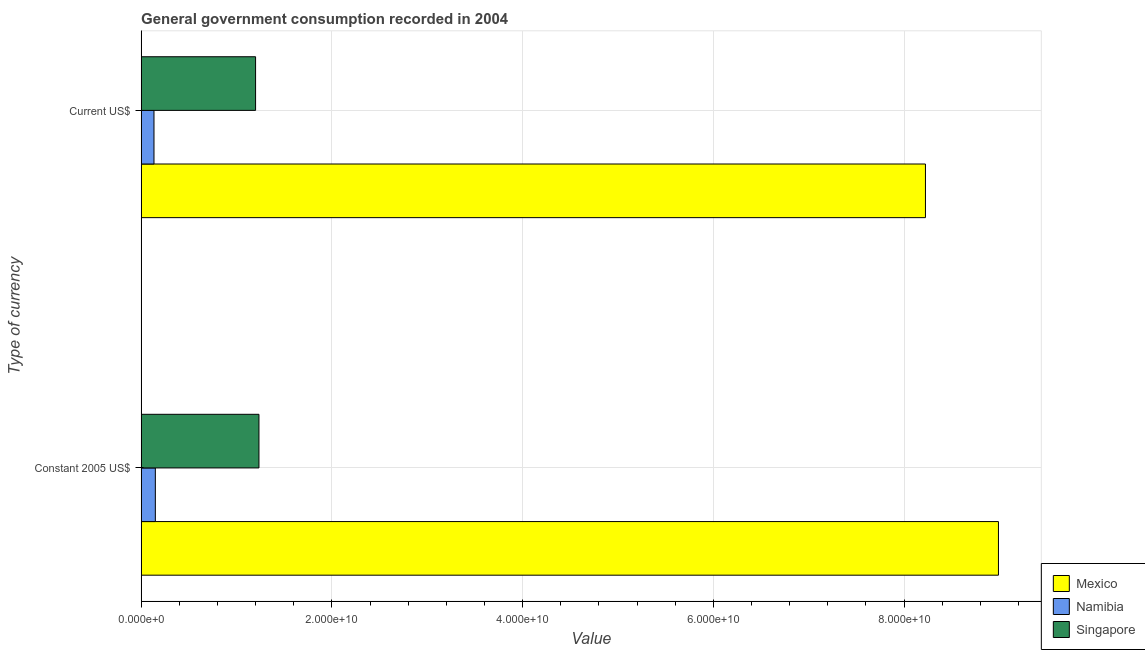How many different coloured bars are there?
Provide a succinct answer. 3. Are the number of bars per tick equal to the number of legend labels?
Your answer should be compact. Yes. What is the label of the 1st group of bars from the top?
Your response must be concise. Current US$. What is the value consumed in current us$ in Singapore?
Keep it short and to the point. 1.20e+1. Across all countries, what is the maximum value consumed in current us$?
Ensure brevity in your answer.  8.22e+1. Across all countries, what is the minimum value consumed in constant 2005 us$?
Provide a succinct answer. 1.49e+09. In which country was the value consumed in constant 2005 us$ maximum?
Your answer should be compact. Mexico. In which country was the value consumed in current us$ minimum?
Your answer should be very brief. Namibia. What is the total value consumed in constant 2005 us$ in the graph?
Offer a very short reply. 1.04e+11. What is the difference between the value consumed in current us$ in Mexico and that in Namibia?
Offer a very short reply. 8.09e+1. What is the difference between the value consumed in current us$ in Namibia and the value consumed in constant 2005 us$ in Mexico?
Provide a succinct answer. -8.86e+1. What is the average value consumed in constant 2005 us$ per country?
Provide a short and direct response. 3.46e+1. What is the difference between the value consumed in current us$ and value consumed in constant 2005 us$ in Singapore?
Your answer should be compact. -3.54e+08. What is the ratio of the value consumed in constant 2005 us$ in Singapore to that in Mexico?
Your answer should be very brief. 0.14. In how many countries, is the value consumed in current us$ greater than the average value consumed in current us$ taken over all countries?
Ensure brevity in your answer.  1. What does the 1st bar from the top in Constant 2005 US$ represents?
Ensure brevity in your answer.  Singapore. What does the 3rd bar from the bottom in Constant 2005 US$ represents?
Your response must be concise. Singapore. How many bars are there?
Your answer should be very brief. 6. What is the difference between two consecutive major ticks on the X-axis?
Provide a short and direct response. 2.00e+1. Does the graph contain any zero values?
Make the answer very short. No. What is the title of the graph?
Ensure brevity in your answer.  General government consumption recorded in 2004. Does "Nicaragua" appear as one of the legend labels in the graph?
Offer a very short reply. No. What is the label or title of the X-axis?
Provide a short and direct response. Value. What is the label or title of the Y-axis?
Your answer should be very brief. Type of currency. What is the Value in Mexico in Constant 2005 US$?
Offer a terse response. 8.99e+1. What is the Value in Namibia in Constant 2005 US$?
Provide a short and direct response. 1.49e+09. What is the Value of Singapore in Constant 2005 US$?
Offer a very short reply. 1.24e+1. What is the Value of Mexico in Current US$?
Offer a very short reply. 8.22e+1. What is the Value of Namibia in Current US$?
Your answer should be very brief. 1.35e+09. What is the Value in Singapore in Current US$?
Ensure brevity in your answer.  1.20e+1. Across all Type of currency, what is the maximum Value of Mexico?
Provide a short and direct response. 8.99e+1. Across all Type of currency, what is the maximum Value in Namibia?
Ensure brevity in your answer.  1.49e+09. Across all Type of currency, what is the maximum Value in Singapore?
Provide a succinct answer. 1.24e+1. Across all Type of currency, what is the minimum Value in Mexico?
Your response must be concise. 8.22e+1. Across all Type of currency, what is the minimum Value of Namibia?
Your answer should be very brief. 1.35e+09. Across all Type of currency, what is the minimum Value of Singapore?
Give a very brief answer. 1.20e+1. What is the total Value of Mexico in the graph?
Ensure brevity in your answer.  1.72e+11. What is the total Value of Namibia in the graph?
Keep it short and to the point. 2.83e+09. What is the total Value in Singapore in the graph?
Make the answer very short. 2.44e+1. What is the difference between the Value in Mexico in Constant 2005 US$ and that in Current US$?
Offer a very short reply. 7.66e+09. What is the difference between the Value in Namibia in Constant 2005 US$ and that in Current US$?
Ensure brevity in your answer.  1.43e+08. What is the difference between the Value of Singapore in Constant 2005 US$ and that in Current US$?
Your answer should be compact. 3.54e+08. What is the difference between the Value in Mexico in Constant 2005 US$ and the Value in Namibia in Current US$?
Give a very brief answer. 8.86e+1. What is the difference between the Value of Mexico in Constant 2005 US$ and the Value of Singapore in Current US$?
Ensure brevity in your answer.  7.79e+1. What is the difference between the Value of Namibia in Constant 2005 US$ and the Value of Singapore in Current US$?
Make the answer very short. -1.05e+1. What is the average Value of Mexico per Type of currency?
Give a very brief answer. 8.61e+1. What is the average Value in Namibia per Type of currency?
Make the answer very short. 1.42e+09. What is the average Value in Singapore per Type of currency?
Offer a very short reply. 1.22e+1. What is the difference between the Value of Mexico and Value of Namibia in Constant 2005 US$?
Your answer should be compact. 8.84e+1. What is the difference between the Value in Mexico and Value in Singapore in Constant 2005 US$?
Offer a terse response. 7.76e+1. What is the difference between the Value in Namibia and Value in Singapore in Constant 2005 US$?
Ensure brevity in your answer.  -1.09e+1. What is the difference between the Value of Mexico and Value of Namibia in Current US$?
Your answer should be compact. 8.09e+1. What is the difference between the Value of Mexico and Value of Singapore in Current US$?
Offer a very short reply. 7.02e+1. What is the difference between the Value of Namibia and Value of Singapore in Current US$?
Your answer should be compact. -1.07e+1. What is the ratio of the Value in Mexico in Constant 2005 US$ to that in Current US$?
Your response must be concise. 1.09. What is the ratio of the Value of Namibia in Constant 2005 US$ to that in Current US$?
Offer a terse response. 1.11. What is the ratio of the Value of Singapore in Constant 2005 US$ to that in Current US$?
Your answer should be compact. 1.03. What is the difference between the highest and the second highest Value of Mexico?
Make the answer very short. 7.66e+09. What is the difference between the highest and the second highest Value in Namibia?
Offer a terse response. 1.43e+08. What is the difference between the highest and the second highest Value of Singapore?
Ensure brevity in your answer.  3.54e+08. What is the difference between the highest and the lowest Value in Mexico?
Offer a very short reply. 7.66e+09. What is the difference between the highest and the lowest Value of Namibia?
Your response must be concise. 1.43e+08. What is the difference between the highest and the lowest Value of Singapore?
Provide a succinct answer. 3.54e+08. 